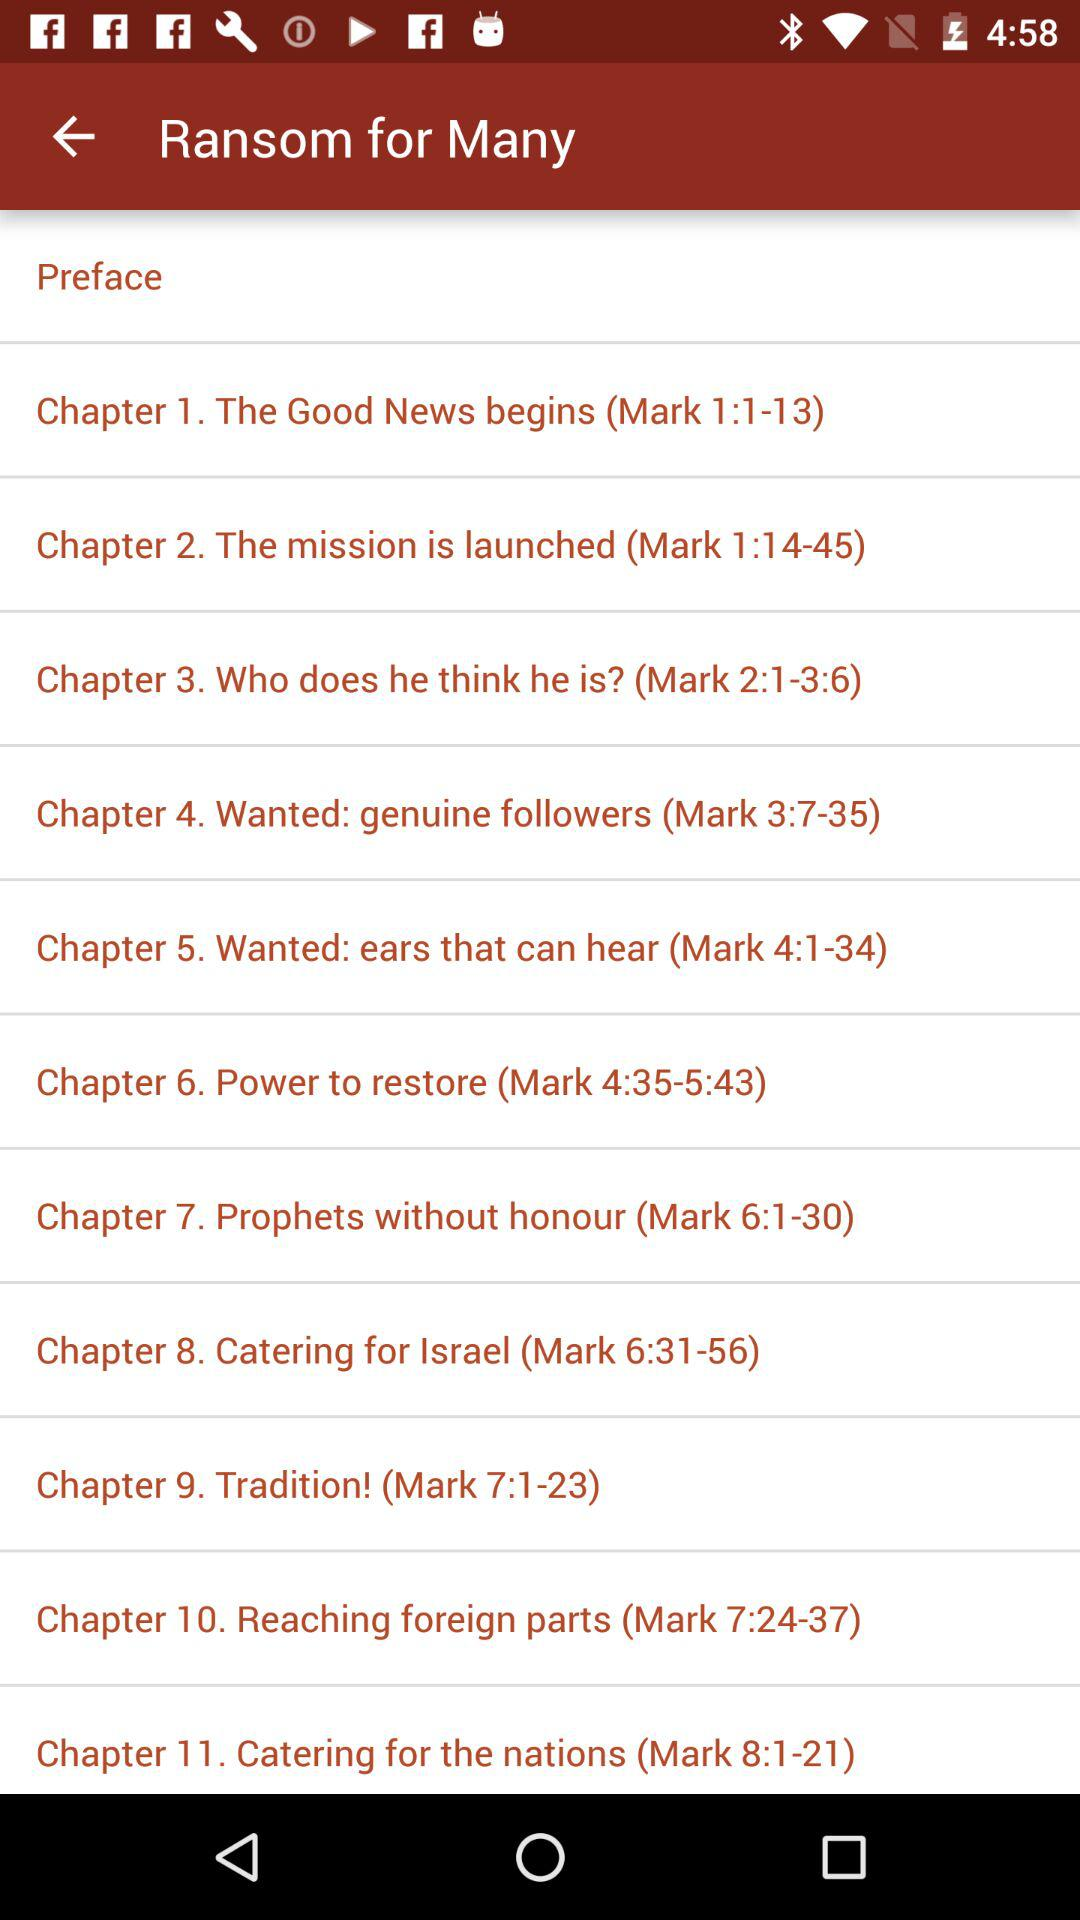How many chapters are in the book before the chapter titled 'Chapter 6. Power to restore'?
Answer the question using a single word or phrase. 5 